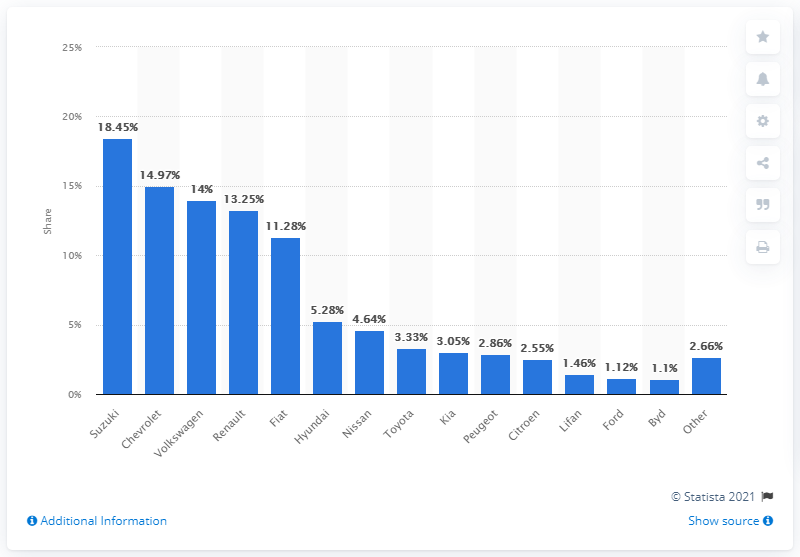Indicate a few pertinent items in this graphic. In 2018, Chevrolet was the bestselling passenger car brand in Uruguay. In 2018, Suzuki was the bestselling passenger car brand in Uruguay. In 2018, Suzuki's unit sales market share in Uruguay was 18.45%. In Uruguay, Volkswagen was the car brand in the third position. 